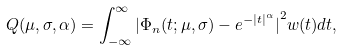Convert formula to latex. <formula><loc_0><loc_0><loc_500><loc_500>Q ( \mu , \sigma , \alpha ) = \int _ { - \infty } ^ { \infty } { | \Phi _ { n } ( t ; \mu , \sigma ) - e ^ { - { | t | } ^ { \alpha } } | } ^ { 2 } w ( t ) d t ,</formula> 